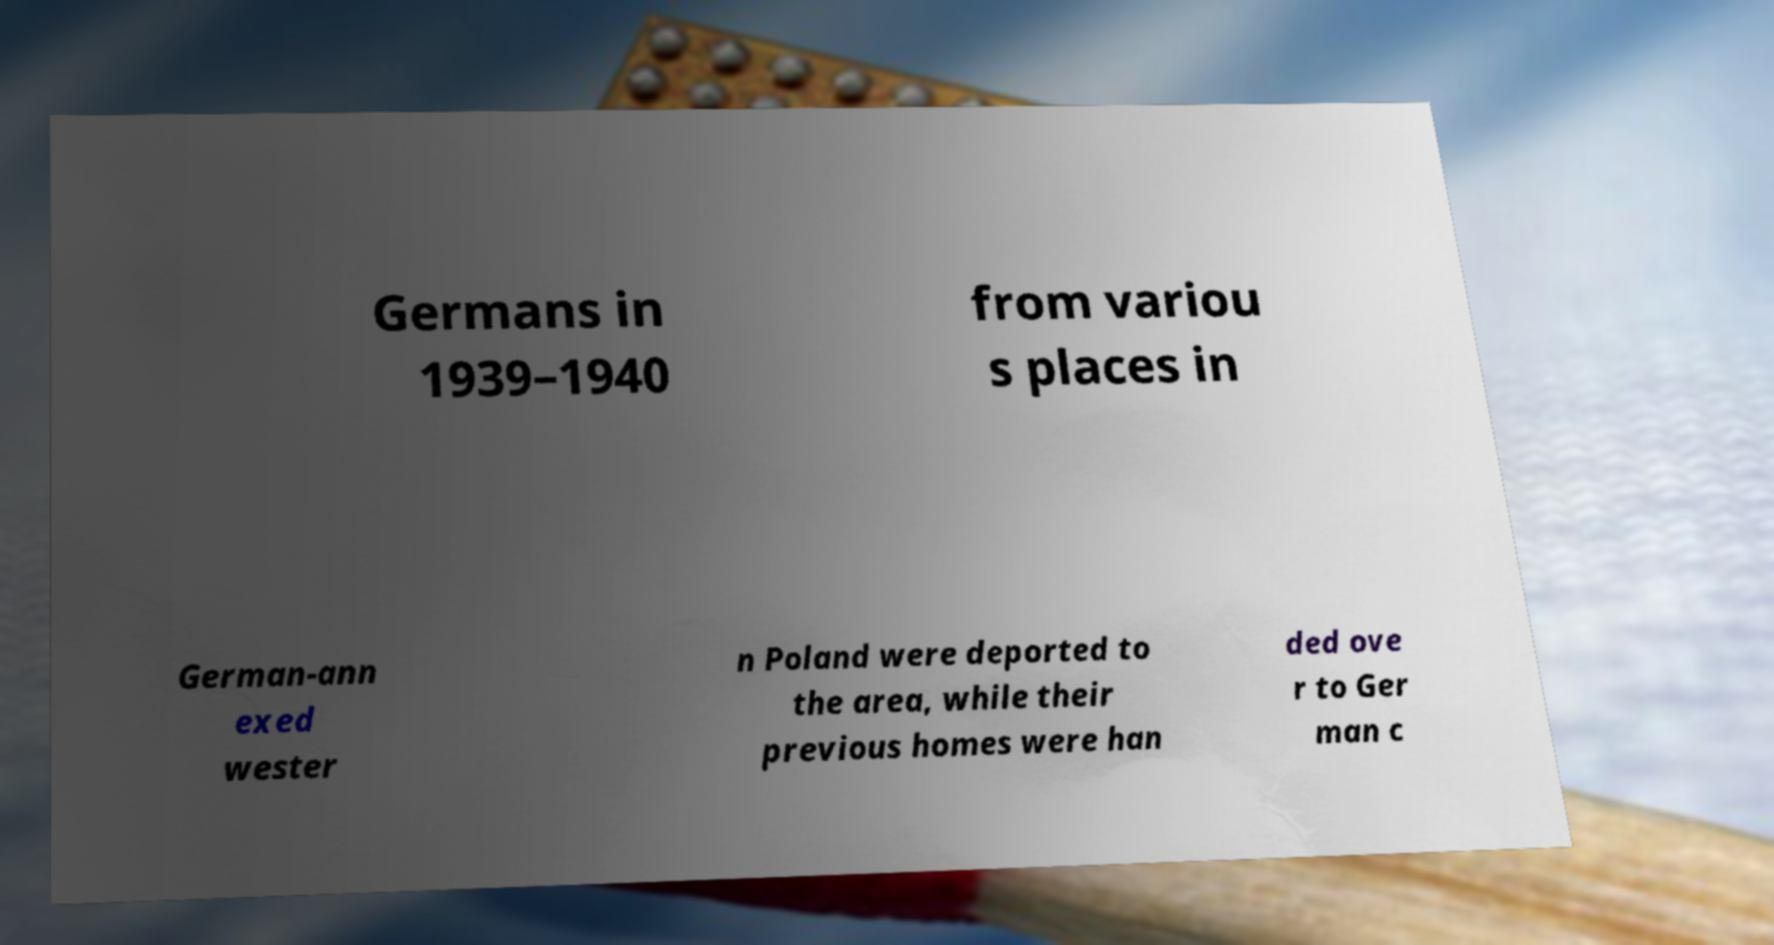What messages or text are displayed in this image? I need them in a readable, typed format. Germans in 1939–1940 from variou s places in German-ann exed wester n Poland were deported to the area, while their previous homes were han ded ove r to Ger man c 